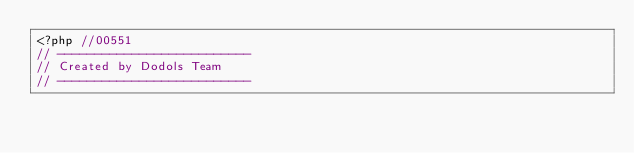Convert code to text. <code><loc_0><loc_0><loc_500><loc_500><_PHP_><?php //00551
// --------------------------
// Created by Dodols Team
// --------------------------</code> 